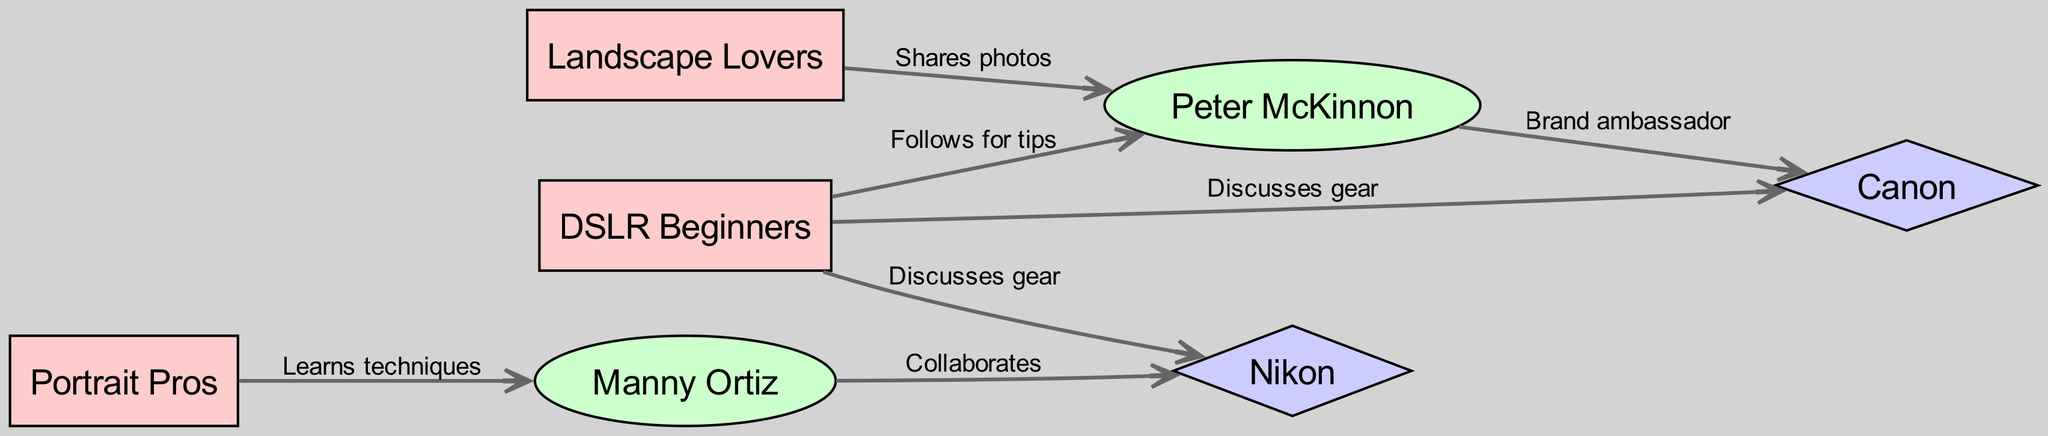What communities are connected to Peter McKinnon? Peter McKinnon is connected to the "DSLR Beginners" community because the edge indicates a "Follows for tips" relationship. He is also connected to the "Landscape Lovers" community through a "Shares photos" relationship.
Answer: DSLR Beginners, Landscape Lovers How many edges are present in the diagram? To determine the number of edges, we must count the relationships listed in the edges section of the data. There are a total of 7 edges connecting various nodes.
Answer: 7 Which influencer is associated with Nikon? Manny Ortiz is the influencer associated with Nikon, as shown by the "Collaborates" relationship with Nikon in the edges.
Answer: Manny Ortiz What type of connection does the DSLR Beginners community have with Canon? The connection between the DSLR Beginners community and Canon is labeled as "Discusses gear," which indicates they engage in discussions about camera equipment.
Answer: Discusses gear What is the primary relationship between Portrait Pros and Manny Ortiz? The primary relationship between the Portrait Pros community and Manny Ortiz is "Learns techniques," indicating that members learn photography techniques from him.
Answer: Learns techniques Which two brands are mentioned in the diagram? The two brands mentioned in the diagram are Canon and Nikon, both identified as separate nodes in the data.
Answer: Canon, Nikon Who is the brand ambassador for Canon according to the diagram? According to the diagram, Peter McKinnon is the brand ambassador for Canon, as indicated by the edge connecting him to Canon labeled "Brand ambassador."
Answer: Peter McKinnon How many communities are represented in the diagram? There are 3 communities represented in the diagram: "DSLR Beginners," "Landscape Lovers," and "Portrait Pros." This can be confirmed by counting the community nodes in the data.
Answer: 3 